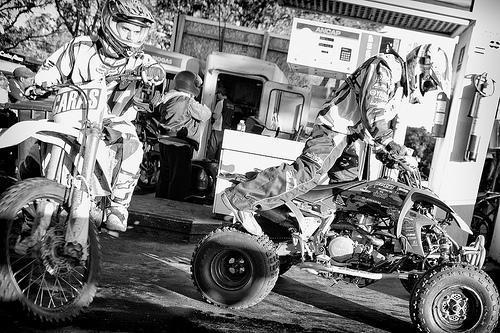How many men are riding?
Give a very brief answer. 2. How many helmets are in the photo?
Give a very brief answer. 3. 